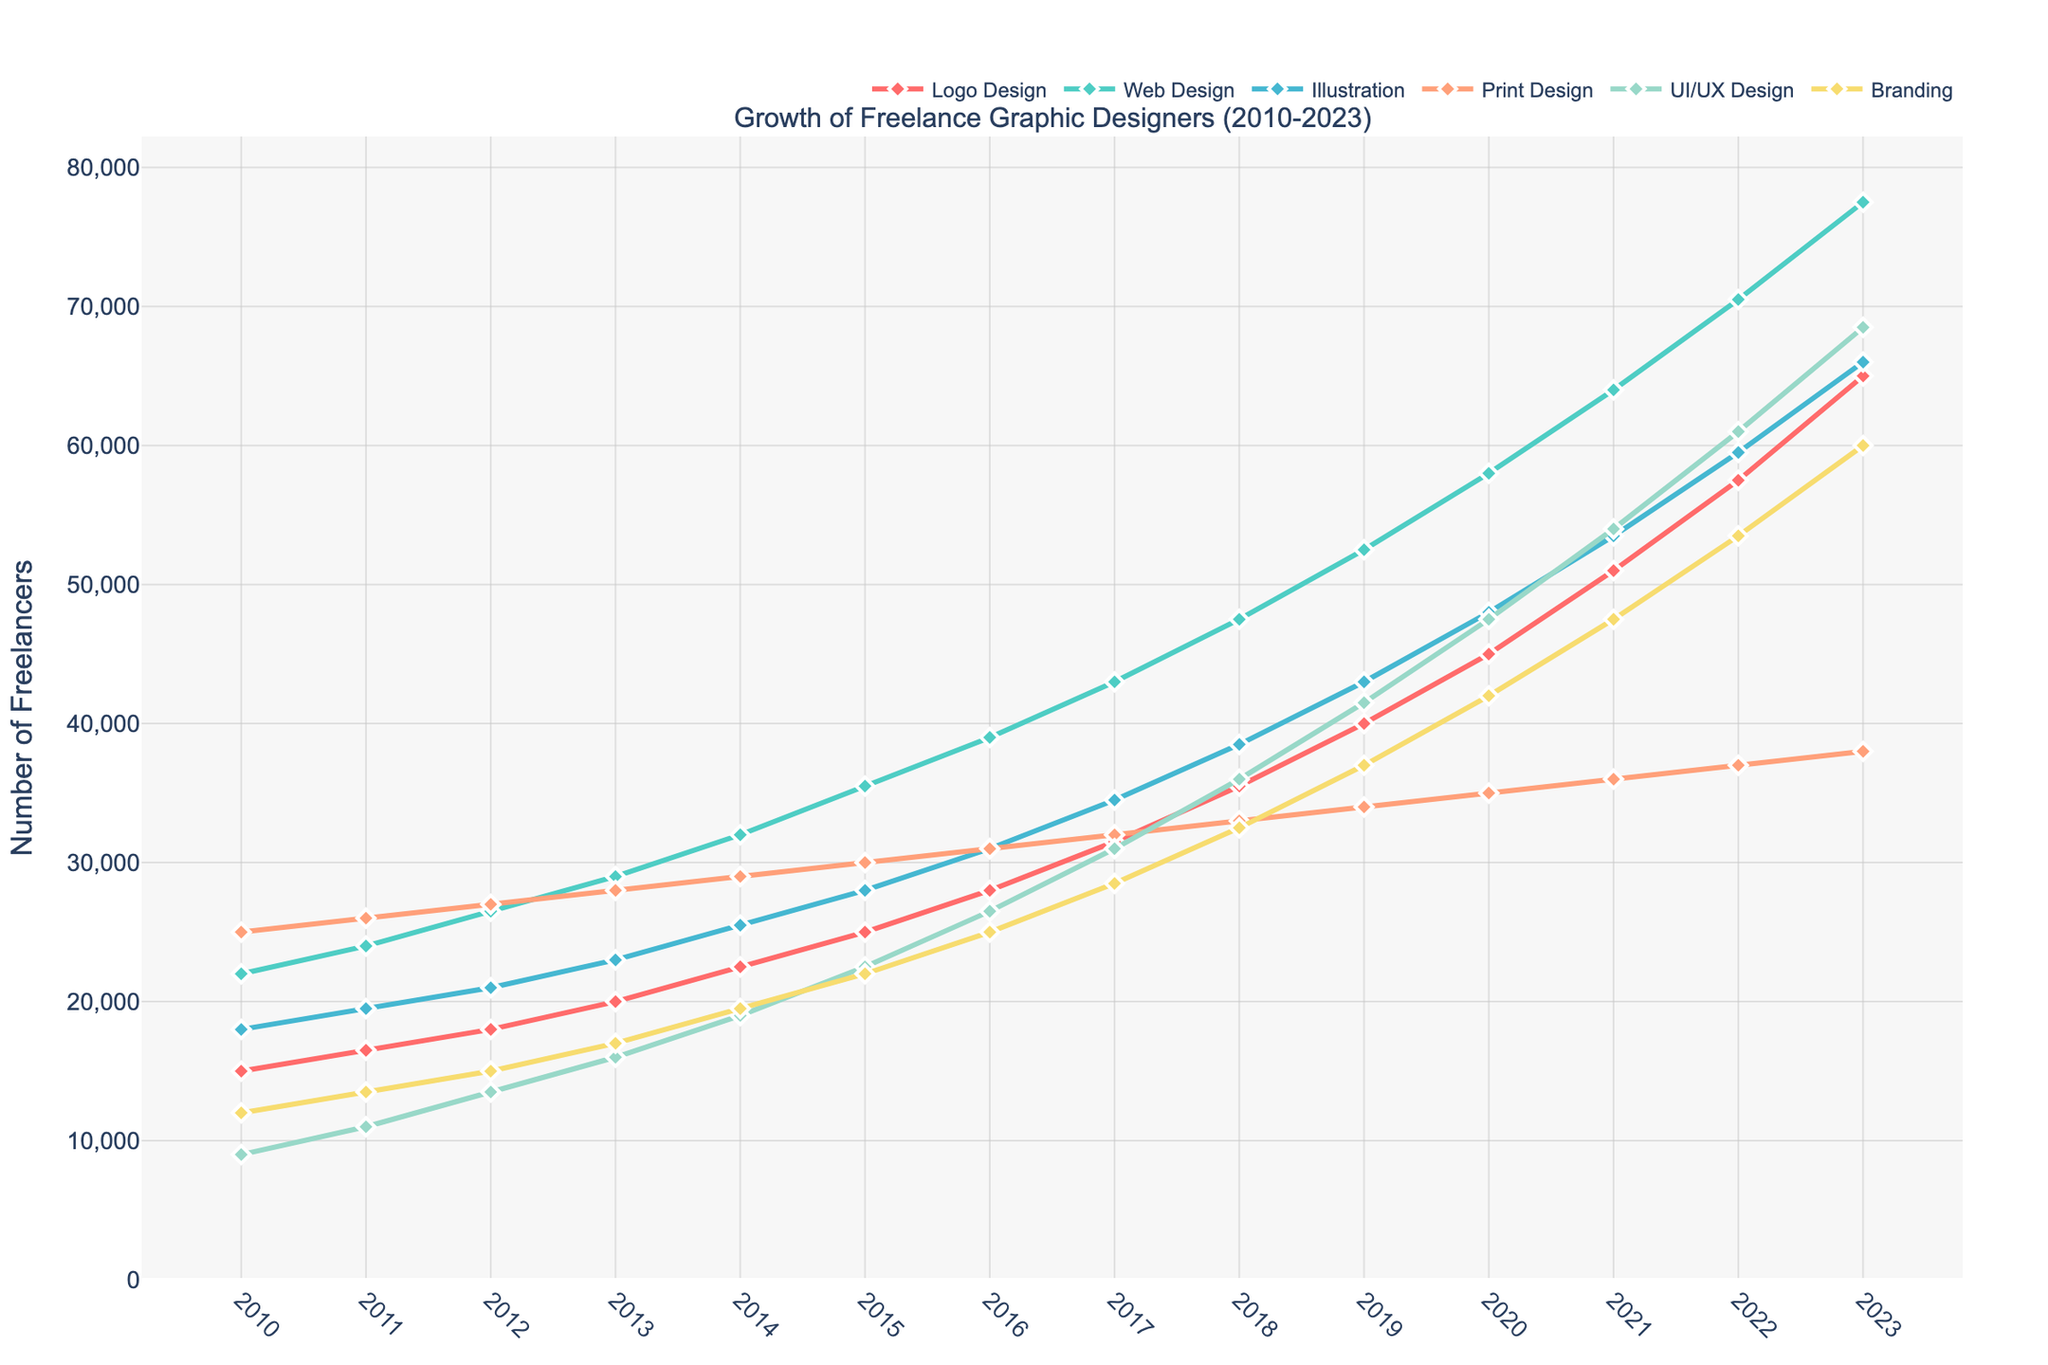what is the total number of freelance Logo Designers and Web Designers in 2023? To find the total, add the values of Logo Designers and Web Designers for 2023: 65000 (Logo Design) + 77500 (Web Design) = 142500
Answer: 142500 Between 2010 and 2023, which specialization saw the highest increase in the number of freelance graphic designers? To identify the highest increase, calculate the difference between 2023 and 2010 for each specialization. The largest increase is: Branding (60000 - 12000 = 48000)
Answer: Branding How does the trend for UI/UX Design compare to Web Design between 2015 and 2020? Compare the changes in values between 2015 and 2020. For UI/UX Design: 47500 - 22500 = 25000. For Web Design: 58000 - 35500 = 22500. UI/UX Design had a higher increase.
Answer: Greater What is the average number of freelance Illustrators between 2011 and 2014? Add values for Illustration from 2011 to 2014 and divide by the number of years: (19500 + 21000 + 23000 + 25500) / 4 = 22250
Answer: 22250 Which specialization had the smallest number of freelance graphic designers in 2010? Review 2010 values for each specialization. The smallest value is 9000 for UI/UX Design.
Answer: UI/UX Design In 2023, how many more freelance UI/UX Designers were there compared to Print Designers? Subtract the number of Print Designers from UI/UX Designers in 2023: 68500 - 38000 = 30500
Answer: 30500 Estimate the year when the number of freelance Web Designers exceeded 50,000. Identify the year when Web Design crossed 50,000. In 2019, the number of Web Designers was 52500.
Answer: 2019 How did Branding trend visually change from 2013 to 2018? Analyze the visual trend for Branding between 2013 (17000) and 2018 (32500). The line indicates a consistent upward trend.
Answer: Upward trend 